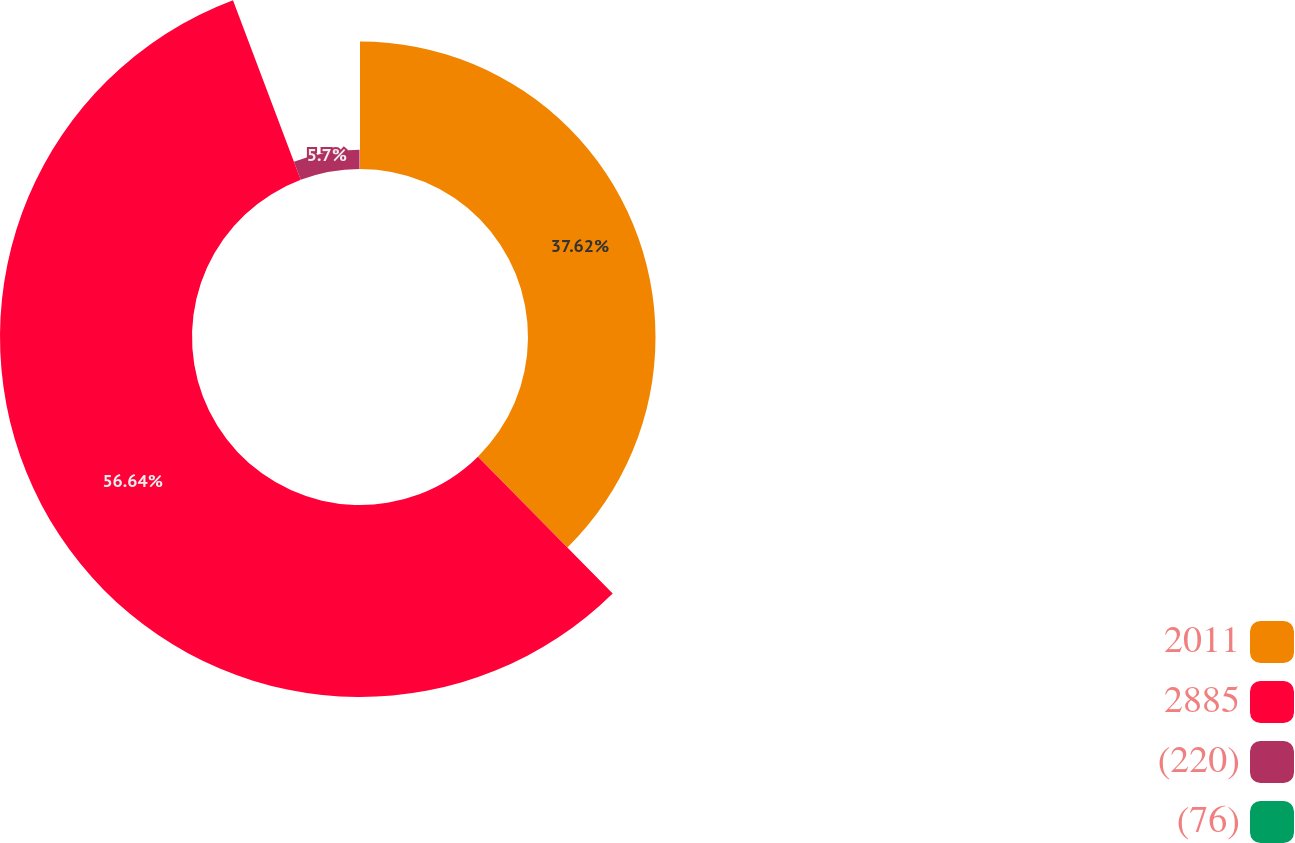Convert chart. <chart><loc_0><loc_0><loc_500><loc_500><pie_chart><fcel>2011<fcel>2885<fcel>(220)<fcel>(76)<nl><fcel>37.62%<fcel>56.65%<fcel>5.7%<fcel>0.04%<nl></chart> 